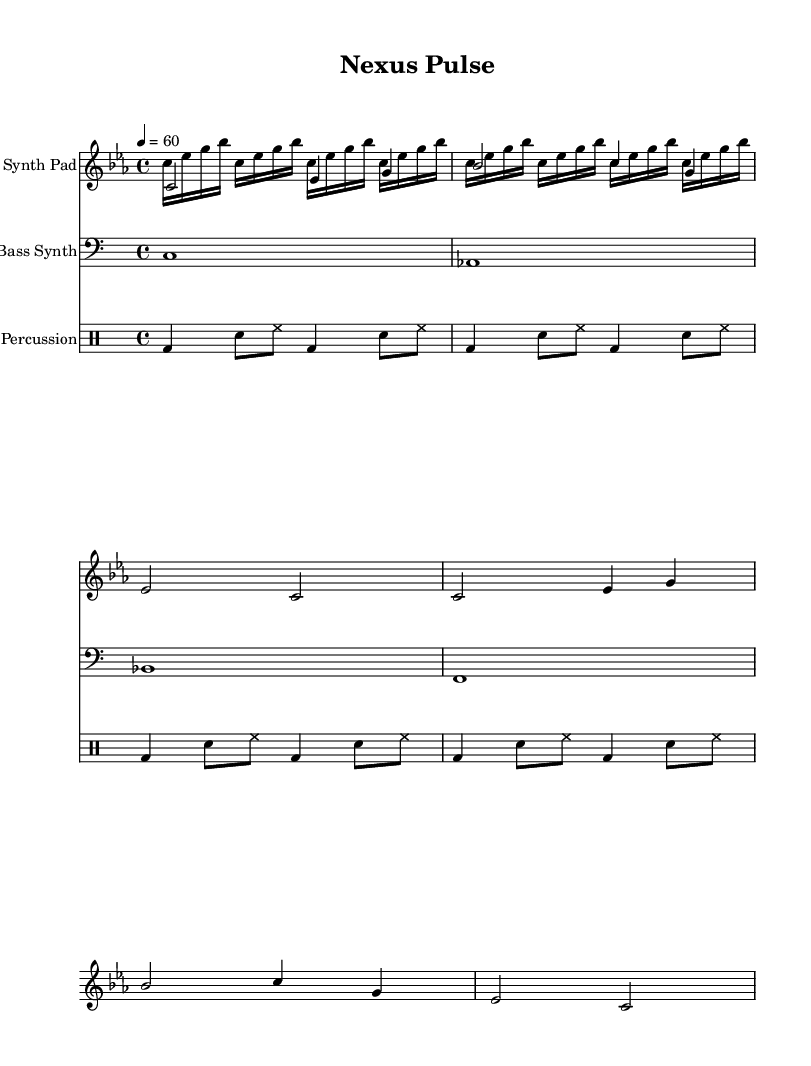What is the key signature of this music? The key signature is C minor, which has three flats: B flat, E flat, and A flat. This can be identified by looking at the key signature section at the beginning of the staff.
Answer: C minor What is the time signature of the piece? The time signature is 4/4, which means there are four beats in each measure, and the quarter note gets one beat. This can be seen at the beginning of the staff where the time signature is notated.
Answer: 4/4 What is the tempo marking of the piece? The tempo marking indicates a speed of 60 beats per minute, which means each quarter note is played at this speed. This tempo indication is typically placed at the start of the score.
Answer: 60 How many measures are in the synth pad section? The synth pad section consists of six measures, which can be counted by looking at the measure bars in the staff notation.
Answer: 6 What type of percussion is used in this piece? The percussion section comprises bass drum, snare drum, and hi-hat, which can be identified in the drummode notation shown in the percussion staff.
Answer: Bass drum, snare drum, hi-hat Which voice is the highest in the score? The highest voice in the score belongs to the synthesizer arpeggiator, which is written at a higher pitch than the other voices, specifically above the synth pad voice.
Answer: Arpeggiator 